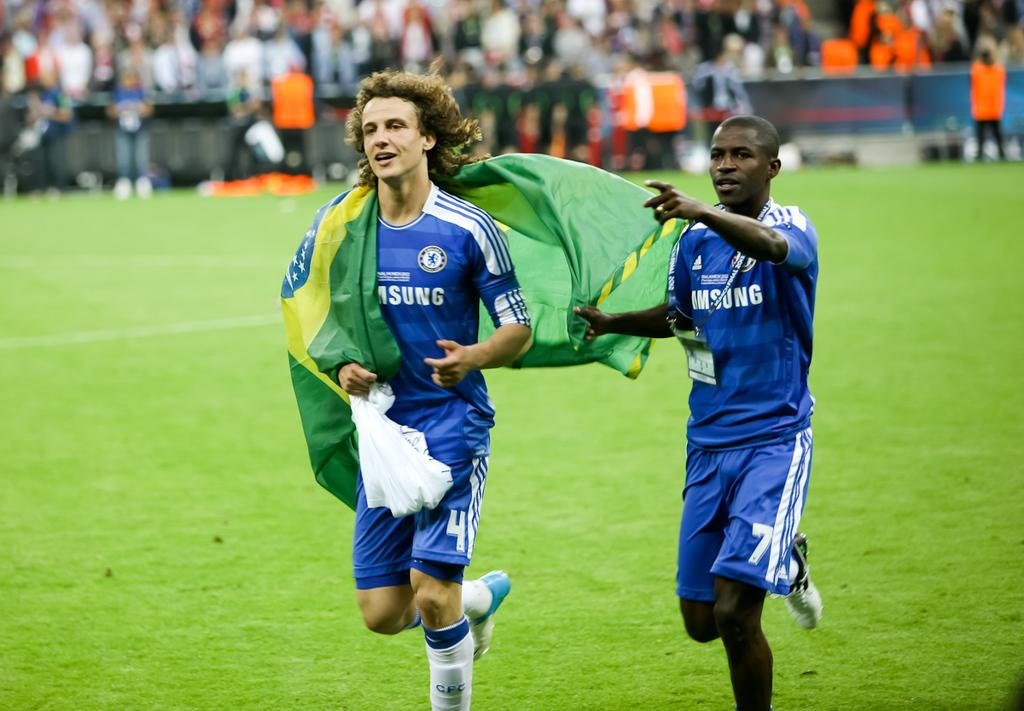<image>
Summarize the visual content of the image. Two soccer players, whose blue jerseys say Samsung on the front, wear numbers 4 and 7. 